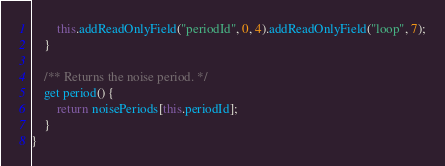<code> <loc_0><loc_0><loc_500><loc_500><_JavaScript_>		this.addReadOnlyField("periodId", 0, 4).addReadOnlyField("loop", 7);
	}

	/** Returns the noise period. */
	get period() {
		return noisePeriods[this.periodId];
	}
}
</code> 